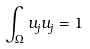Convert formula to latex. <formula><loc_0><loc_0><loc_500><loc_500>\int _ { \Omega } u _ { j } u _ { j } = 1</formula> 